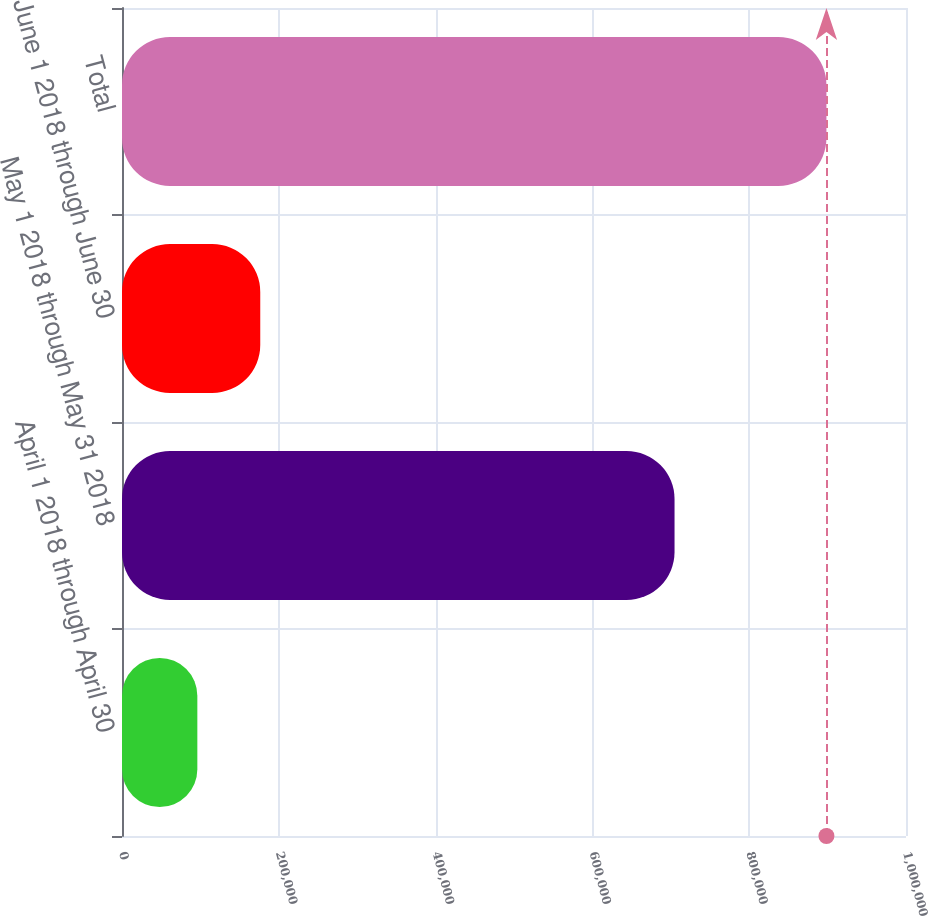Convert chart to OTSL. <chart><loc_0><loc_0><loc_500><loc_500><bar_chart><fcel>April 1 2018 through April 30<fcel>May 1 2018 through May 31 2018<fcel>June 1 2018 through June 30<fcel>Total<nl><fcel>96100<fcel>704770<fcel>176342<fcel>898517<nl></chart> 